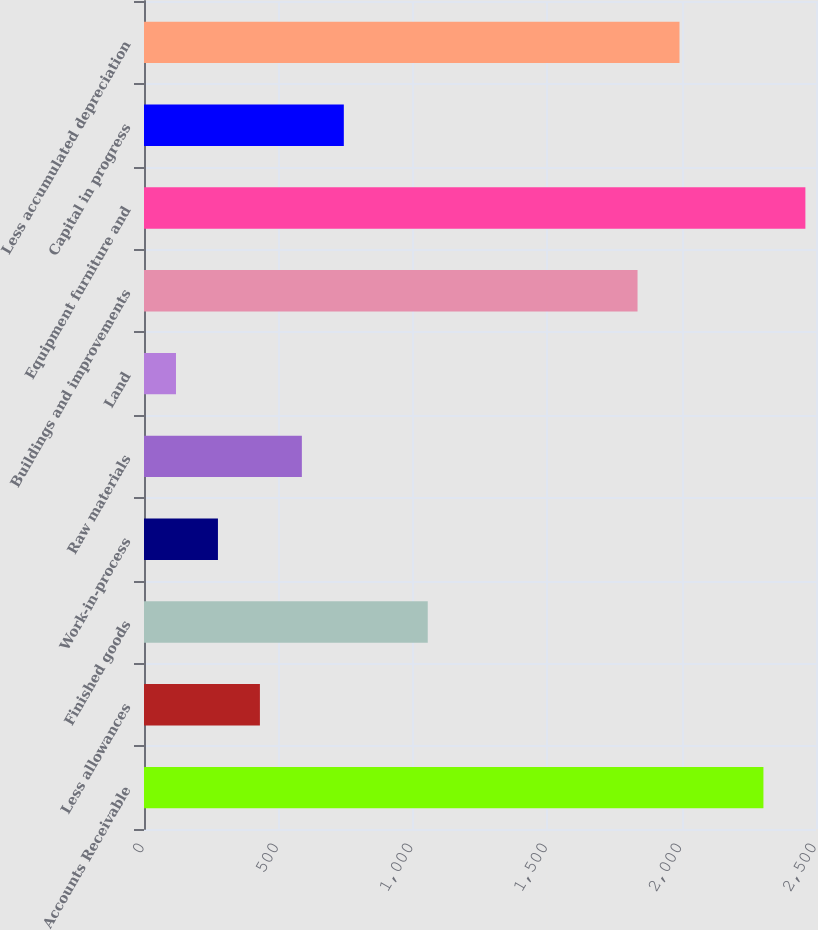Convert chart. <chart><loc_0><loc_0><loc_500><loc_500><bar_chart><fcel>Accounts Receivable<fcel>Less allowances<fcel>Finished goods<fcel>Work-in-process<fcel>Raw materials<fcel>Land<fcel>Buildings and improvements<fcel>Equipment furniture and<fcel>Capital in progress<fcel>Less accumulated depreciation<nl><fcel>2304.4<fcel>431.2<fcel>1055.6<fcel>275.1<fcel>587.3<fcel>119<fcel>1836.1<fcel>2460.5<fcel>743.4<fcel>1992.2<nl></chart> 